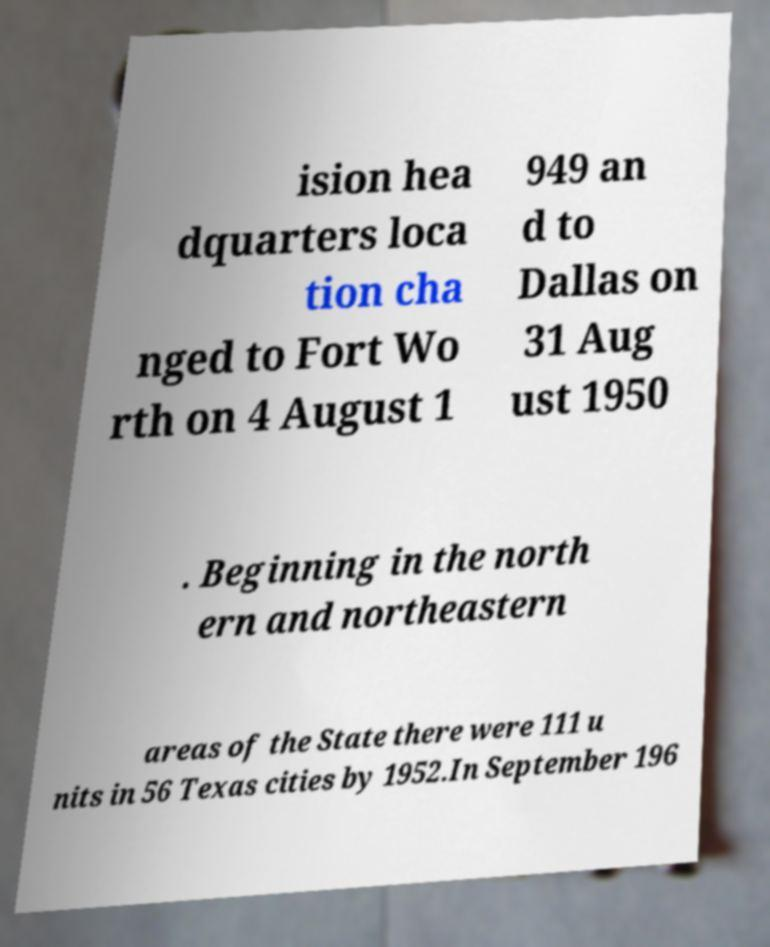What messages or text are displayed in this image? I need them in a readable, typed format. ision hea dquarters loca tion cha nged to Fort Wo rth on 4 August 1 949 an d to Dallas on 31 Aug ust 1950 . Beginning in the north ern and northeastern areas of the State there were 111 u nits in 56 Texas cities by 1952.In September 196 